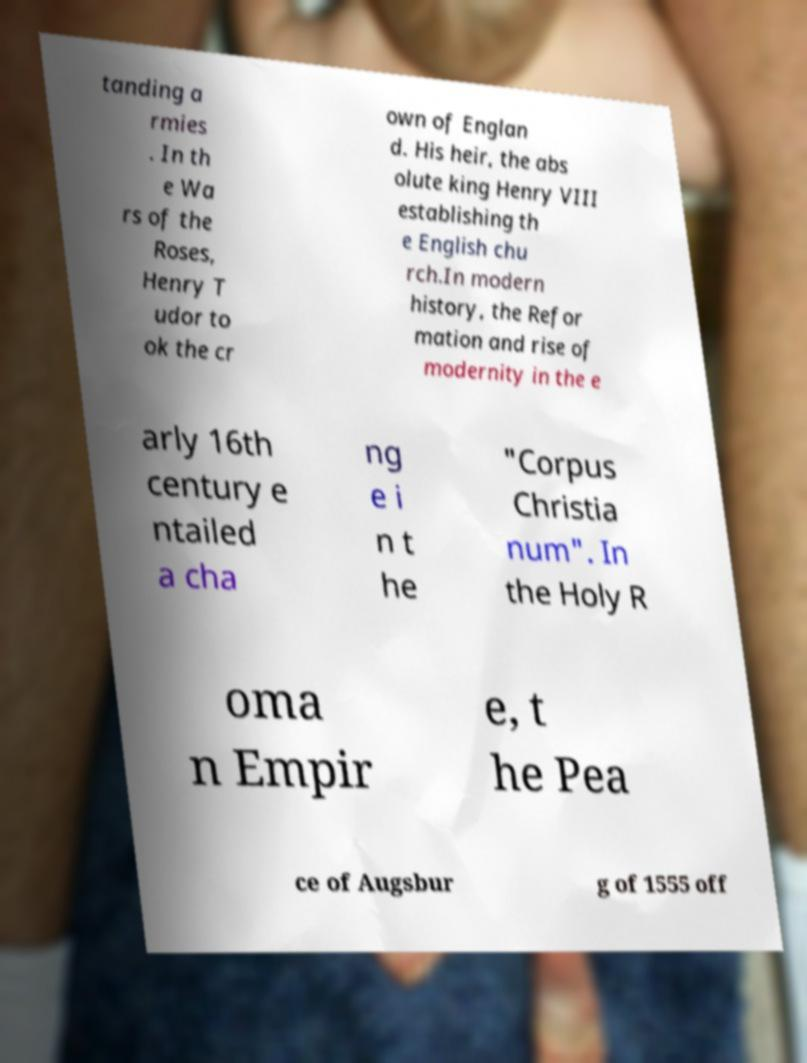Can you read and provide the text displayed in the image?This photo seems to have some interesting text. Can you extract and type it out for me? tanding a rmies . In th e Wa rs of the Roses, Henry T udor to ok the cr own of Englan d. His heir, the abs olute king Henry VIII establishing th e English chu rch.In modern history, the Refor mation and rise of modernity in the e arly 16th century e ntailed a cha ng e i n t he "Corpus Christia num". In the Holy R oma n Empir e, t he Pea ce of Augsbur g of 1555 off 